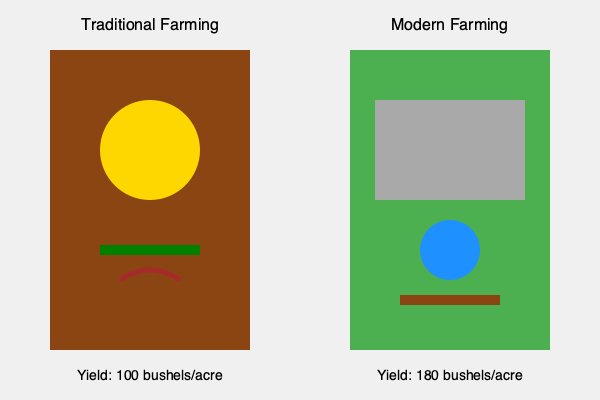Based on the visual comparison of traditional vs. modern farming techniques, what is the percentage increase in yield when using modern farming methods compared to traditional methods? To calculate the percentage increase in yield, we'll follow these steps:

1. Identify the yields:
   - Traditional farming yield: 100 bushels/acre
   - Modern farming yield: 180 bushels/acre

2. Calculate the difference in yield:
   $180 - 100 = 80$ bushels/acre

3. Calculate the percentage increase:
   Percentage increase = $\frac{\text{Increase}}{\text{Original}} \times 100\%$
   
   $\frac{80}{100} \times 100\% = 0.8 \times 100\% = 80\%$

Therefore, the percentage increase in yield when using modern farming methods compared to traditional methods is 80%.
Answer: 80% 